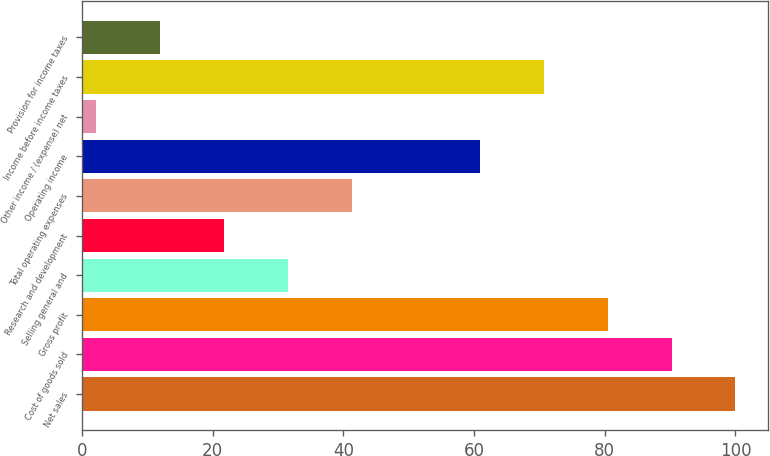Convert chart. <chart><loc_0><loc_0><loc_500><loc_500><bar_chart><fcel>Net sales<fcel>Cost of goods sold<fcel>Gross profit<fcel>Selling general and<fcel>Research and development<fcel>Total operating expenses<fcel>Operating income<fcel>Other income / (expense) net<fcel>Income before income taxes<fcel>Provision for income taxes<nl><fcel>100<fcel>90.22<fcel>80.44<fcel>31.54<fcel>21.76<fcel>41.32<fcel>60.88<fcel>2.2<fcel>70.66<fcel>11.98<nl></chart> 